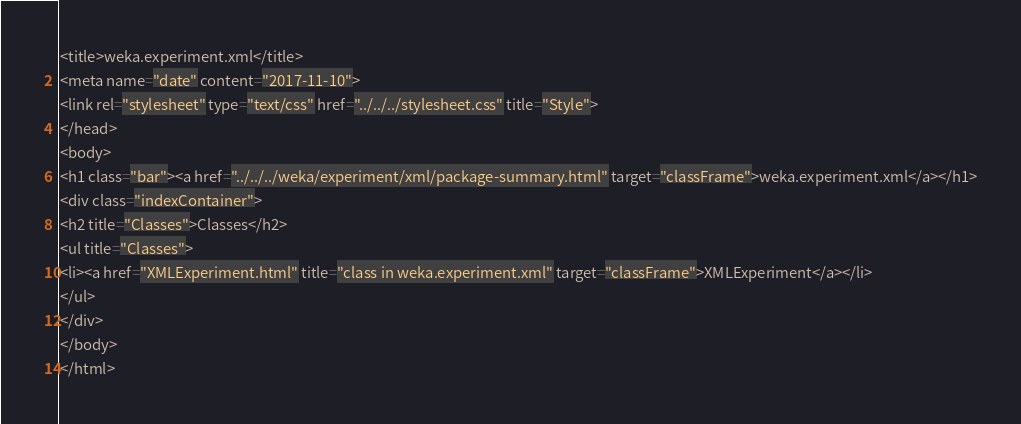Convert code to text. <code><loc_0><loc_0><loc_500><loc_500><_HTML_><title>weka.experiment.xml</title>
<meta name="date" content="2017-11-10">
<link rel="stylesheet" type="text/css" href="../../../stylesheet.css" title="Style">
</head>
<body>
<h1 class="bar"><a href="../../../weka/experiment/xml/package-summary.html" target="classFrame">weka.experiment.xml</a></h1>
<div class="indexContainer">
<h2 title="Classes">Classes</h2>
<ul title="Classes">
<li><a href="XMLExperiment.html" title="class in weka.experiment.xml" target="classFrame">XMLExperiment</a></li>
</ul>
</div>
</body>
</html>
</code> 